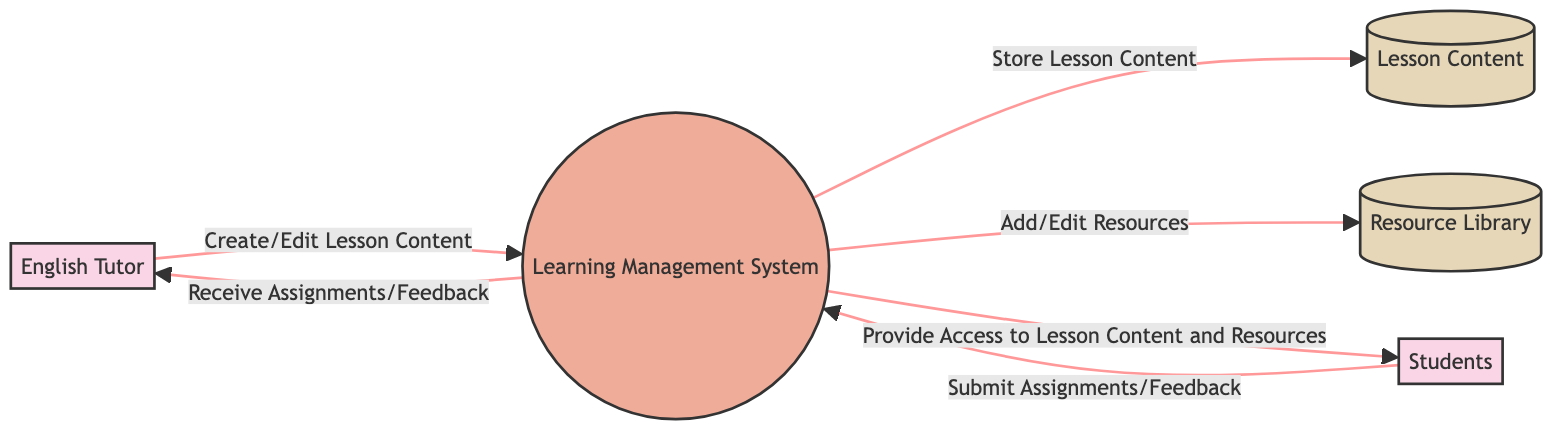What is the external entity responsible for creating lesson content? The diagram identifies "English Tutor" as the external entity responsible for creating and managing lesson content, indicated by the box labeled "ET" which is connected to the Learning Management System.
Answer: English Tutor How many data stores are present in the diagram? The diagram contains two data stores, labeled "Lesson Content" and "Resource Library," both represented as boxes in the diagram, making it easy to count them.
Answer: 2 What data flow occurs between the Learning Management System and Students? The diagram shows that the Learning Management System provides access to lesson content and resources to the Students, indicated by the directed arrow labeled "Provide Access to Lesson Content and Resources."
Answer: Provide Access to Lesson Content and Resources Who submits assignments and feedback to the Learning Management System? The diagram indicates that "Students" are responsible for submitting assignments and feedback, represented by the directed arrow labeled "Submit Assignments/Feedback" flowing from Students to the Learning Management System.
Answer: Students What two actions does the English Tutor perform regarding lesson content? According to the diagram, the English Tutor is involved in "Create/Edit Lesson Content" and receives "Assignments/Feedback" from the Learning Management System, both actions indicated by arrows leading to and from the tutor.
Answer: Create/Edit Lesson Content; Receive Assignments/Feedback How does the Learning Management System influence the Resource Library? The diagram specifies that the Learning Management System updates the Resource Library through the action labeled "Add/Edit Resources," which is shown as a directed flow from the Learning Management System to the Resource Library.
Answer: Add/Edit Resources What is the purpose of the Learning Management System? The diagram emphasizes that the Learning Management System is designed to store and manage lesson content and resources, as depicted in its description within the diagram.
Answer: Store and manage lesson content and resources Which entity receives feedback from the Learning Management System? The diagram clearly shows that the entity receiving feedback is the "English Tutor," as indicated by the directed flow labeled "Receive Assignments/Feedback" from the Learning Management System to the tutor.
Answer: English Tutor 